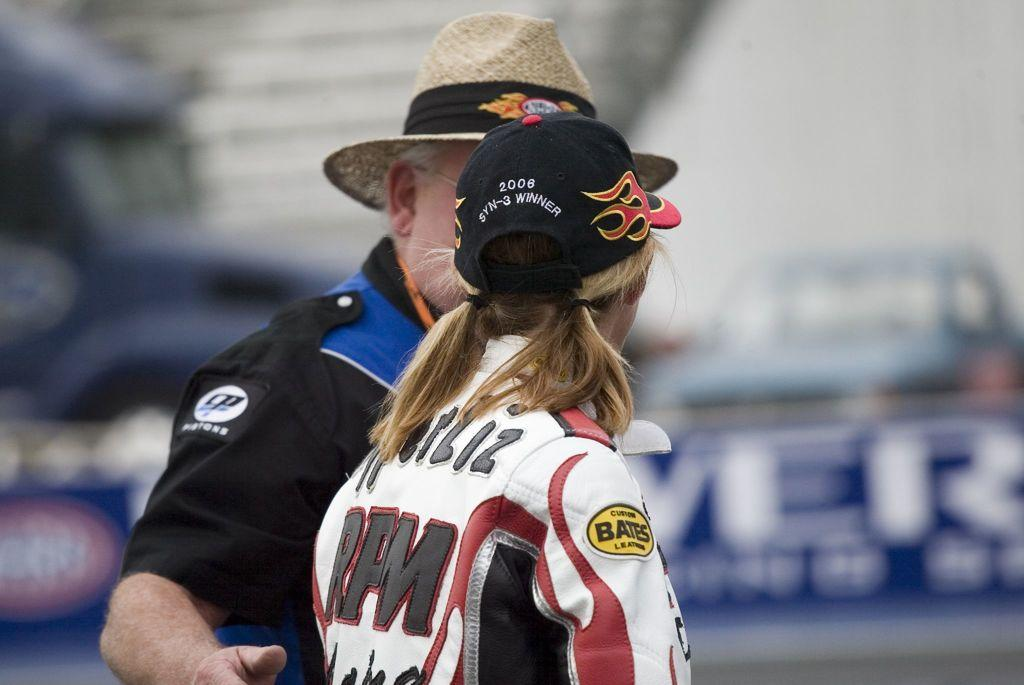<image>
Share a concise interpretation of the image provided. A man in a straw hat talks to a women wearing a black hat that says 2006 SYN-3 Winner on it. 